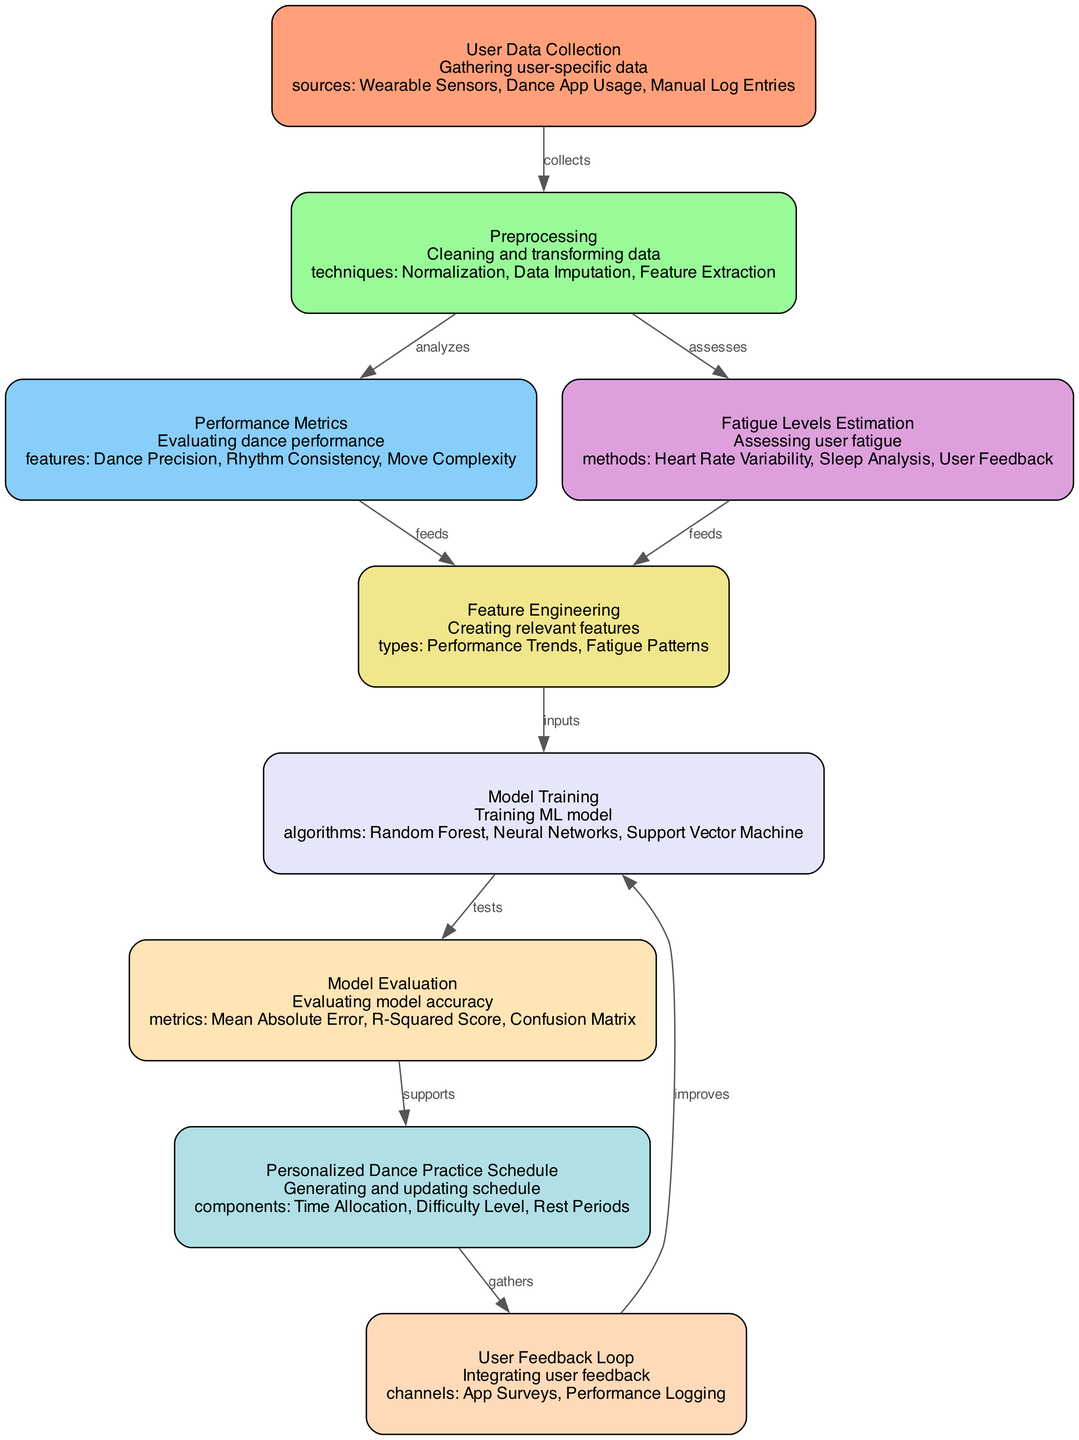What is the total number of nodes in the diagram? The diagram includes nine distinct nodes, each representing a different component in the process. To find the total, we simply count each one listed in the data.
Answer: 9 What method does the "Fatigue Levels Estimation" node use? The node for "Fatigue Levels Estimation" indicates three specific methods which are listed: Heart Rate Variability, Sleep Analysis, and User Feedback. We can select any one of them, as the question asks for a method.
Answer: Heart Rate Variability Which node collects data for the preprocessing step? The edge labeled "collects" points from "User Data Collection" to "Preprocessing." This indicates that "User Data Collection" is responsible for gathering the data necessary for subsequent processing.
Answer: User Data Collection What are the performance metrics evaluated in the diagram? The node "Performance Metrics" lists three specific features that evaluate dance performance: Dance Precision, Rhythm Consistency, and Move Complexity. These features encompass the assessment criteria for performance.
Answer: Dance Precision, Rhythm Consistency, Move Complexity Which algorithms are used in the "Model Training" process? The "Model Training" node details three algorithms used to train the machine learning model: Random Forest, Neural Networks, and Support Vector Machine. This gives insight into the methods being employed for the training phase.
Answer: Random Forest, Neural Networks, Support Vector Machine What type of feedback does the "User Feedback Loop" gather? The "User Feedback Loop" node states that it gathers feedback through channels such as App Surveys and Performance Logging. These are the specific means by which user input is collected to improve the overall model.
Answer: App Surveys, Performance Logging Which node directly supports the generation of the personalized dance practice schedule? The edge labeled "supports" leads from "Model Evaluation" to "Personalized Dance Practice Schedule," indicating that the results from the model evaluation contribute directly to creating the personalized schedule for dance practice.
Answer: Model Evaluation Name a technique used in data preprocessing. The "Preprocessing" node specifies a few techniques used to clean and transform the data, one of which is simply "Normalization." This method is commonly used to scale data before analysis.
Answer: Normalization What flows into the "Feature Engineering" node? The "Feature Engineering" node receives inputs from both "Performance Metrics" and "Fatigue Levels Estimation," as indicated by the respective edges labeled "feeds." This shows the integration of information from these areas to create relevant features.
Answer: Performance Metrics, Fatigue Levels Estimation 